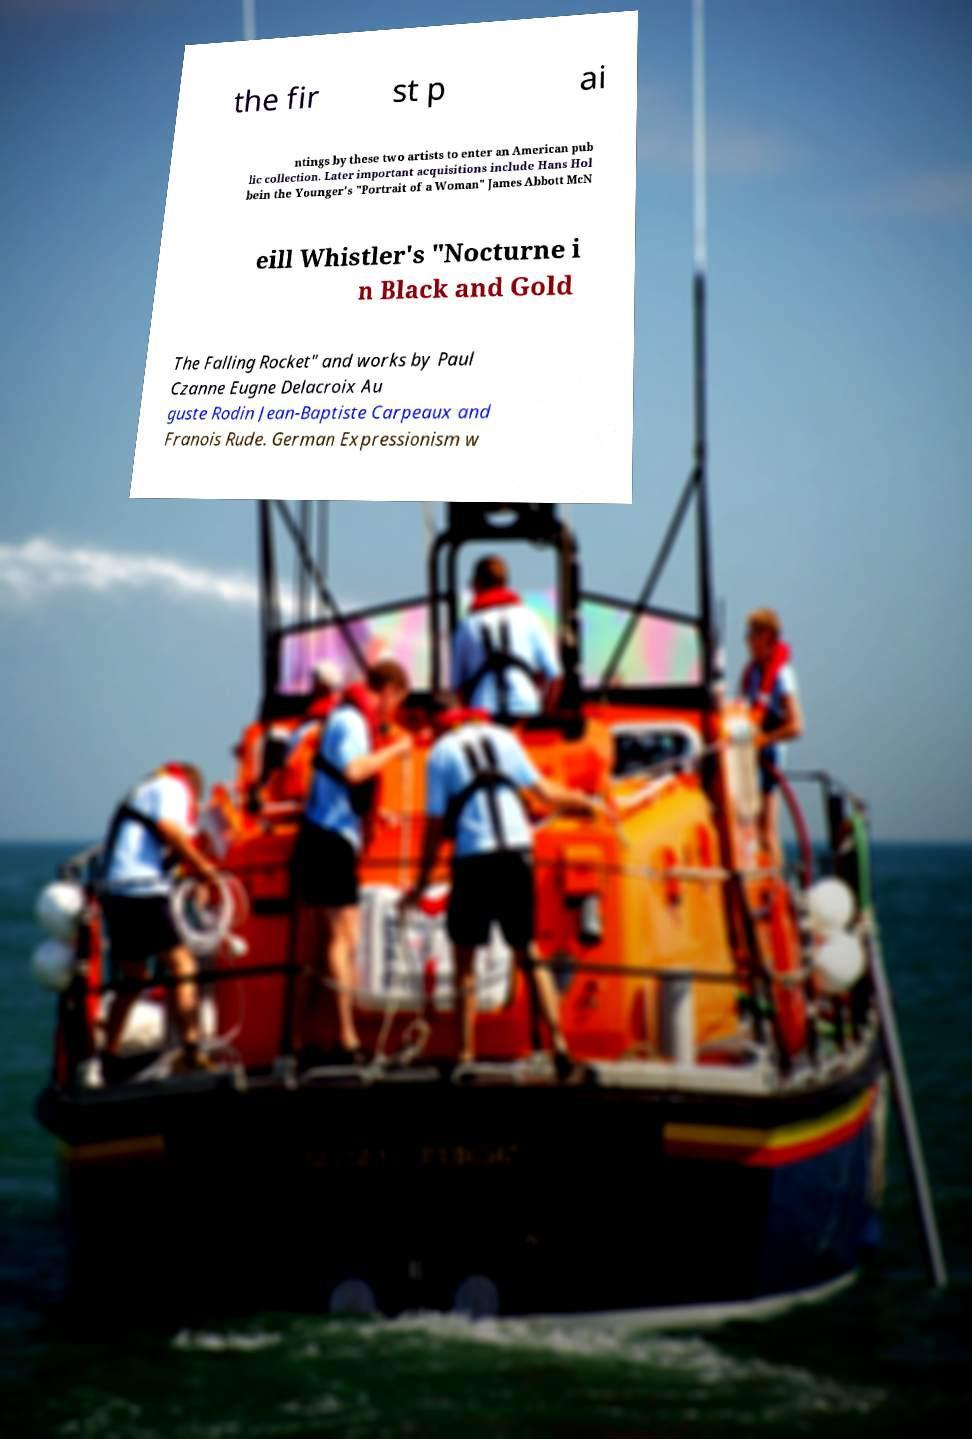What messages or text are displayed in this image? I need them in a readable, typed format. the fir st p ai ntings by these two artists to enter an American pub lic collection. Later important acquisitions include Hans Hol bein the Younger's "Portrait of a Woman" James Abbott McN eill Whistler's "Nocturne i n Black and Gold The Falling Rocket" and works by Paul Czanne Eugne Delacroix Au guste Rodin Jean-Baptiste Carpeaux and Franois Rude. German Expressionism w 